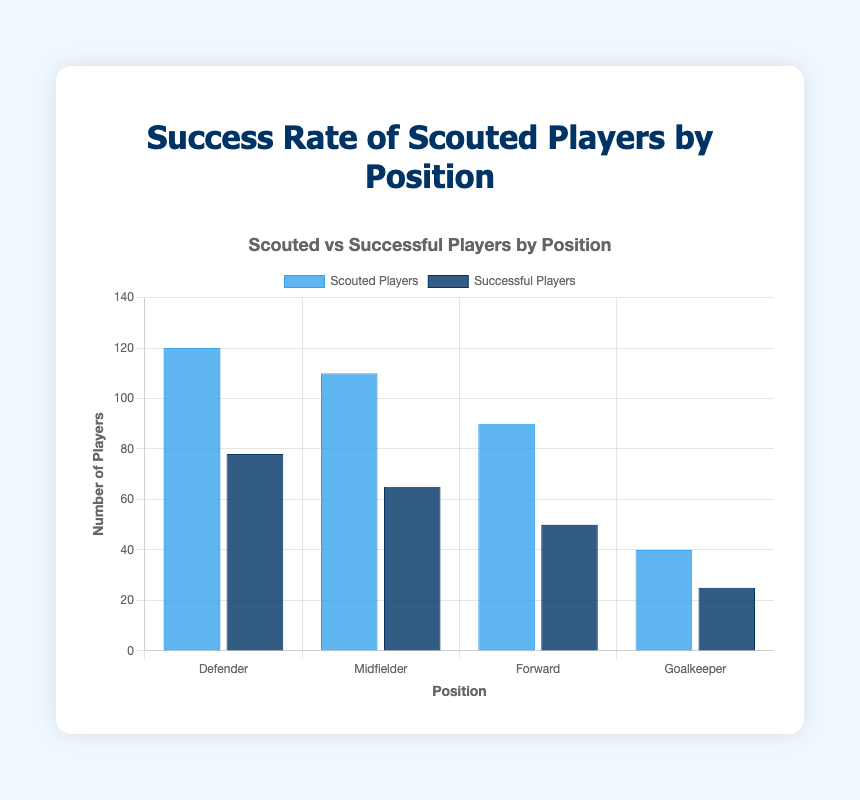Which position has the highest number of scouted players? By looking at the bar representing the number of scouted players, the height of the bar for Defenders is the tallest, indicating it has the highest count.
Answer: Defender Which position has the highest success rate? The tooltip information shows that Defenders have a success rate of 65%, Midfielders 59%, Forwards 56%, and Goalkeepers 63%. The Defender position has the highest success rate.
Answer: Defender How many more scouted players are there in the Defender position compared to Goalkeeper? The number of scouted players for Defenders is 120, and for Goalkeepers, it is 40. The difference is 120 - 40.
Answer: 80 What is the total number of scouted players across all positions? Summing up the number of scouted players: 120 (Defender) + 110 (Midfielder) + 90 (Forward) + 40 (Goalkeeper) = 360.
Answer: 360 What is the average success rate of the players? The success rates are 65%, 59%, 56%, and 63%. Adding them: 65 + 59 + 56 + 63 = 243, then dividing by 4 gives the average 243 / 4 = 60.75%.
Answer: 60.75% How many successful players are there for the Forward position? Referring to the tooltip or the bar labeled for Successful Players and the Forward position, the number is 50.
Answer: 50 Which two positions have the closest number of successful players? By comparing the heights of the dark blue bars, Midfielders (65 successful players) and Forwards (50 successful players) have the closest values.
Answer: Midfielder and Forward Is the success rate for Goalkeepers higher or lower than that for Midfielders? The success rate for Goalkeepers is 63%, whereas for Midfielders it is 59%. Goalkeepers have a higher success rate.
Answer: Higher What is the success rate difference between the highest and lowest success rates? The highest success rate is 65% (Defender) and the lowest is 56% (Forward). The difference is 65% - 56% = 9%.
Answer: 9% 